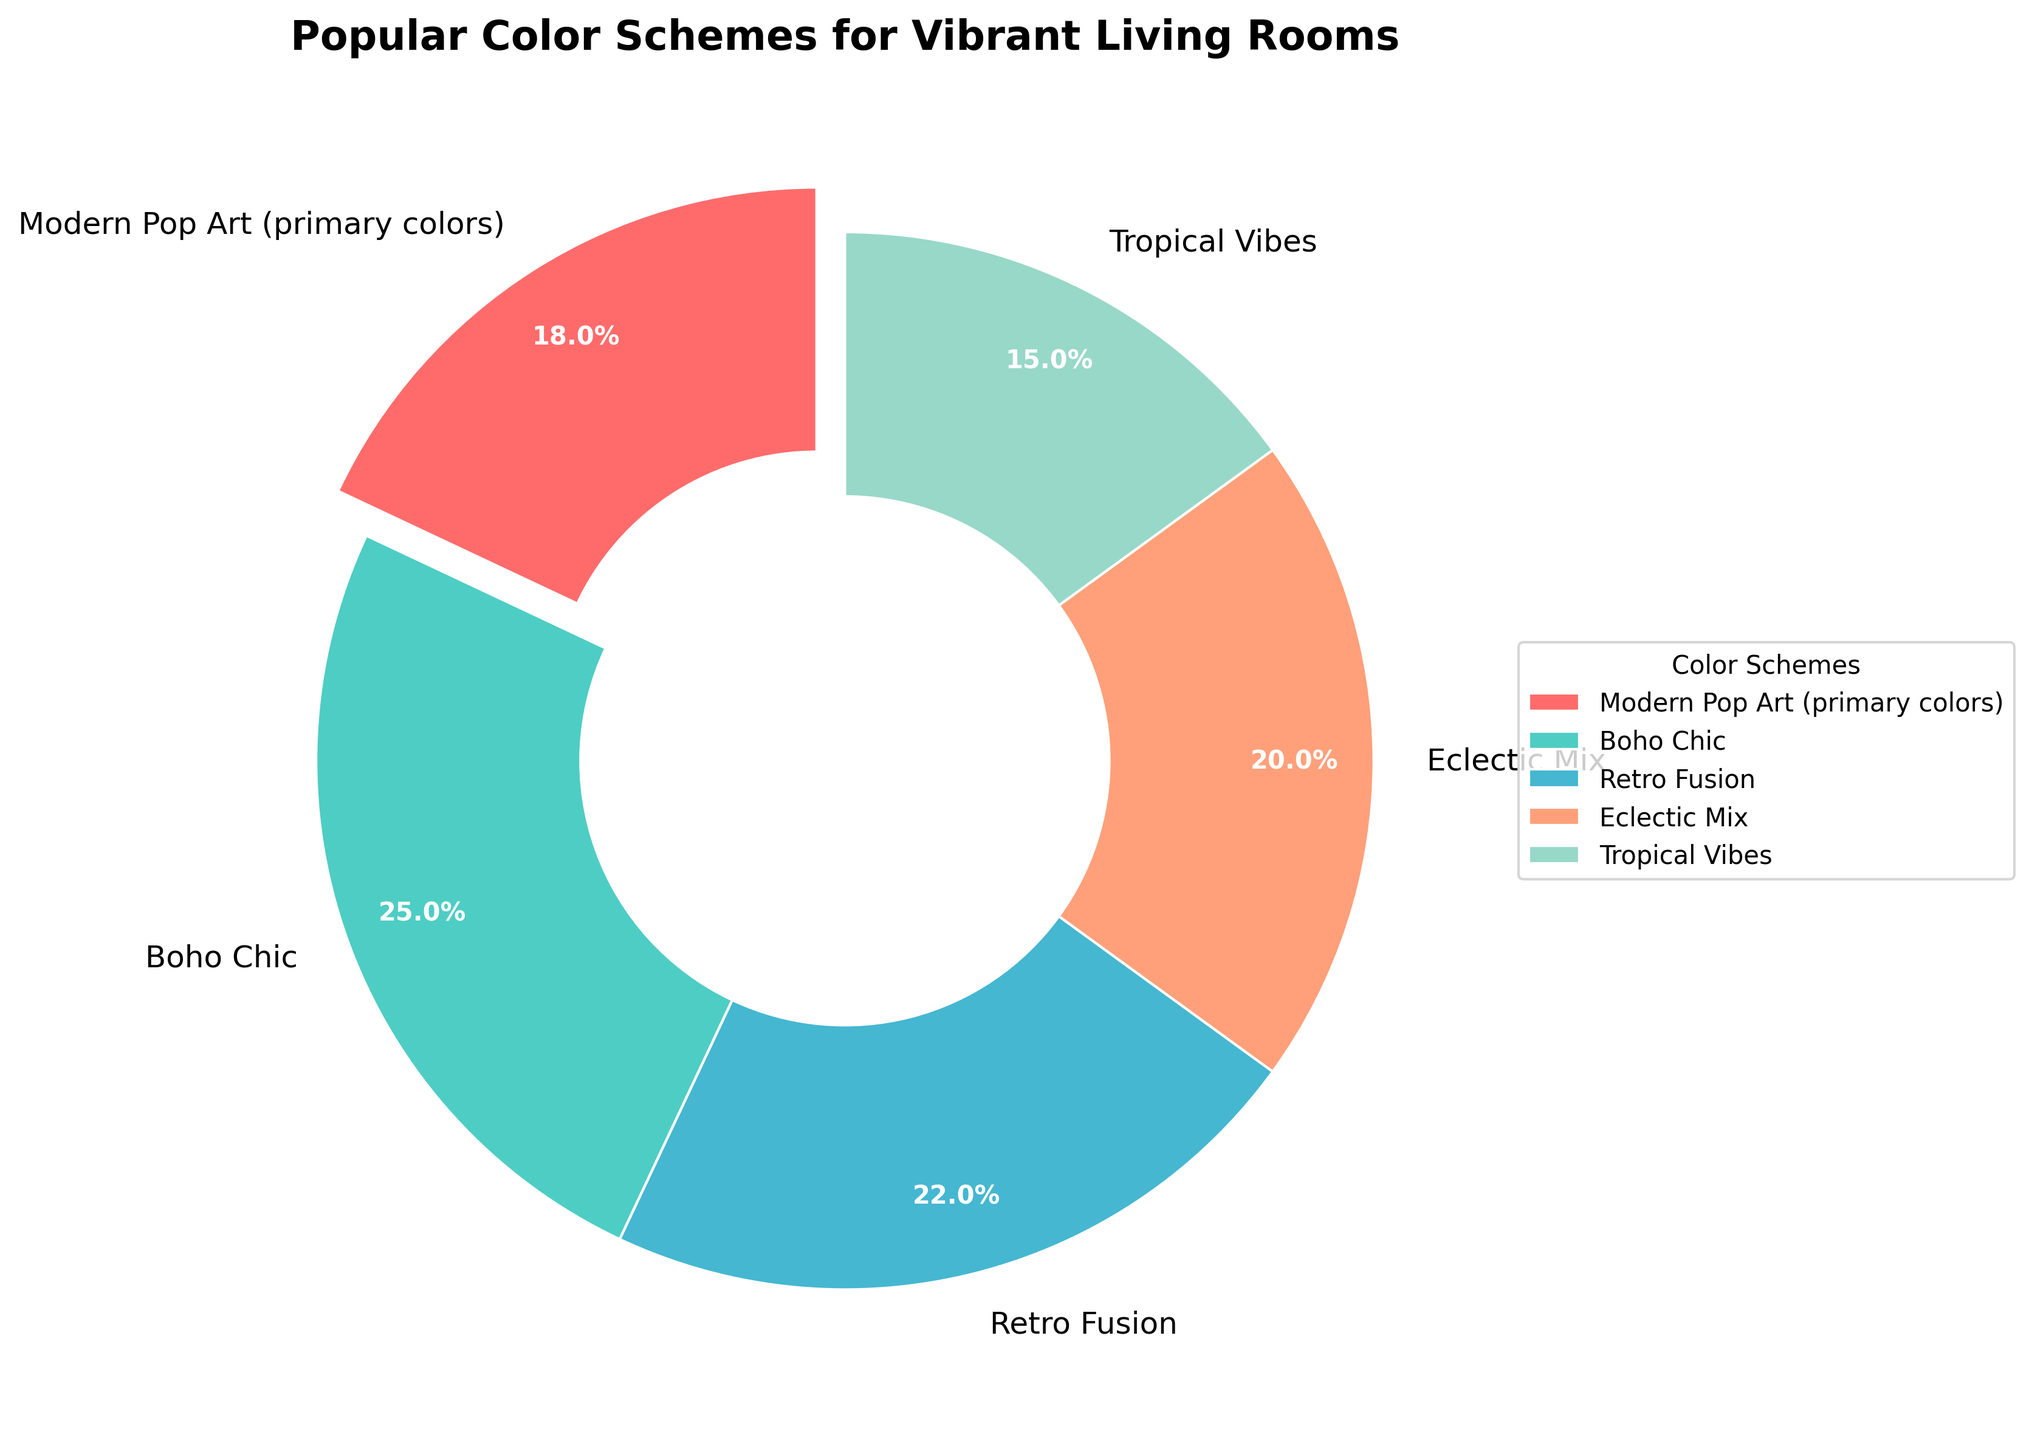Which color scheme occupies the largest portion of the pie chart? The color scheme "Boho Chic" occupies the largest portion of the pie chart with 25%. This can be determined by looking at the percentages given for each slice in the chart.
Answer: "Boho Chic" Which color schemes together make up more than 50% of the pie chart? "Boho Chic" (25%) and "Retro Fusion" (22%) together make up 47%. Adding "Eclectic Mix" (20%) and the sum is 67%, which is more than 50%.
Answer: "Boho Chic", "Retro Fusion", "Eclectic Mix" What is the combined percentage of "Modern Pop Art (primary colors)" and "Tropical Vibes"? From the chart, "Modern Pop Art (primary colors)" is 18% and "Tropical Vibes" is 15%. Adding these together gives 18% + 15% = 33%.
Answer: 33% Which two color schemes combined have the smallest total percentage? The color schemes "Tropical Vibes" (15%) and "Modern Pop Art (primary colors)" (18%) have the smallest total at 33%. This is less than any other pair combination in the chart.
Answer: "Tropical Vibes" and "Modern Pop Art (primary colors)" What visual attribute represents the data for the color scheme "Boho Chic"? The color scheme "Boho Chic" is represented by the largest segment in the pie chart and is typically highlighted in a distinctive color (verify if it's color-coded in a noticeable tone).
Answer: largest segment Which color scheme has just a slightly higher percentage than "Eclectic Mix"? From the given percentages, "Retro Fusion" has a slightly higher percentage (22%) compared to "Eclectic Mix" (20%).
Answer: "Retro Fusion" Is "Modern Pop Art (primary colors)" one of the top three color schemes by percentage? No, "Modern Pop Art (primary colors)" has a percentage of 18%, which does not place it in the top three (Boho Chic - 25%, Retro Fusion - 22%, Eclectic Mix - 20%).
Answer: No How many color schemes are represented in the pie chart? The chart lists "Modern Pop Art (primary colors)" along with 4 additional color schemes, making a total of 5 distinct color schemes shown.
Answer: 5 